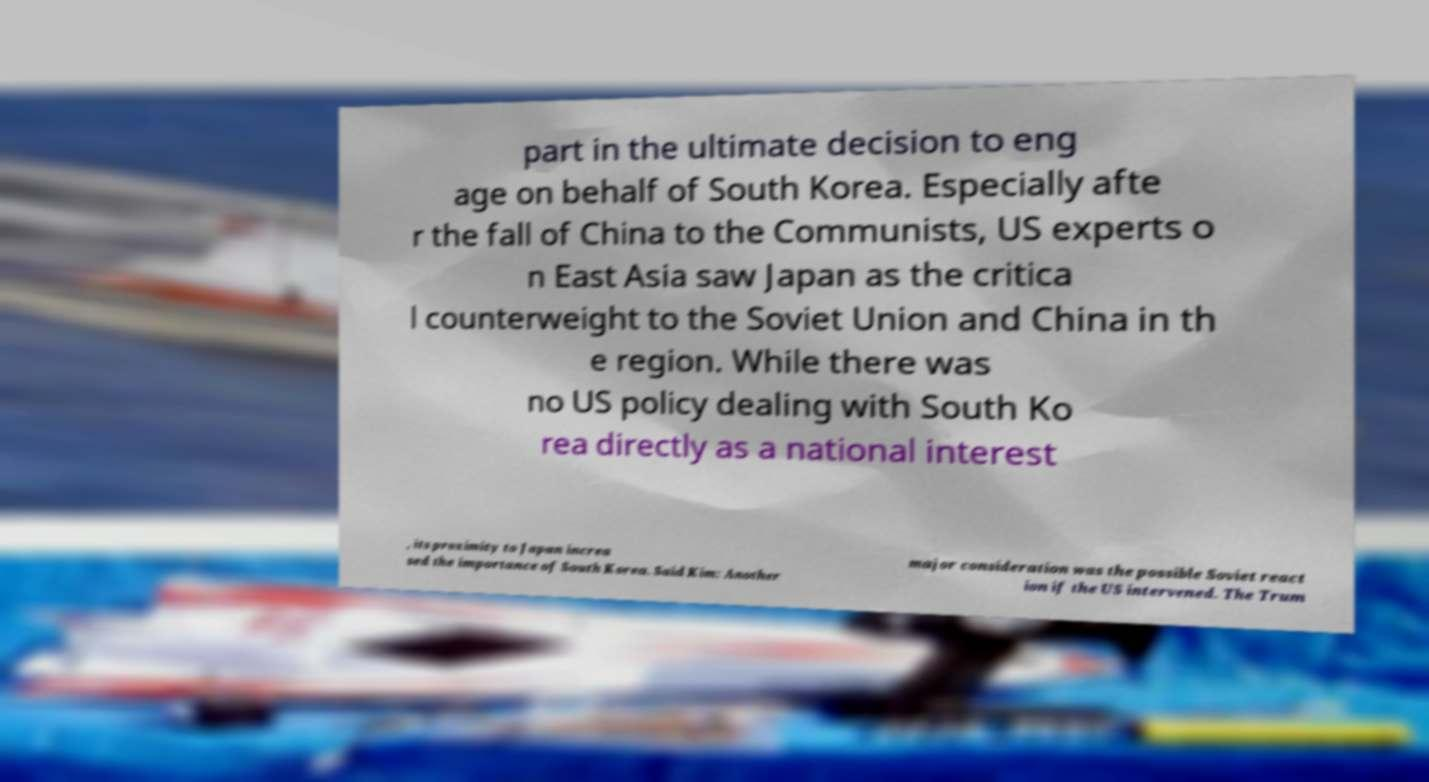Could you assist in decoding the text presented in this image and type it out clearly? part in the ultimate decision to eng age on behalf of South Korea. Especially afte r the fall of China to the Communists, US experts o n East Asia saw Japan as the critica l counterweight to the Soviet Union and China in th e region. While there was no US policy dealing with South Ko rea directly as a national interest , its proximity to Japan increa sed the importance of South Korea. Said Kim: Another major consideration was the possible Soviet react ion if the US intervened. The Trum 